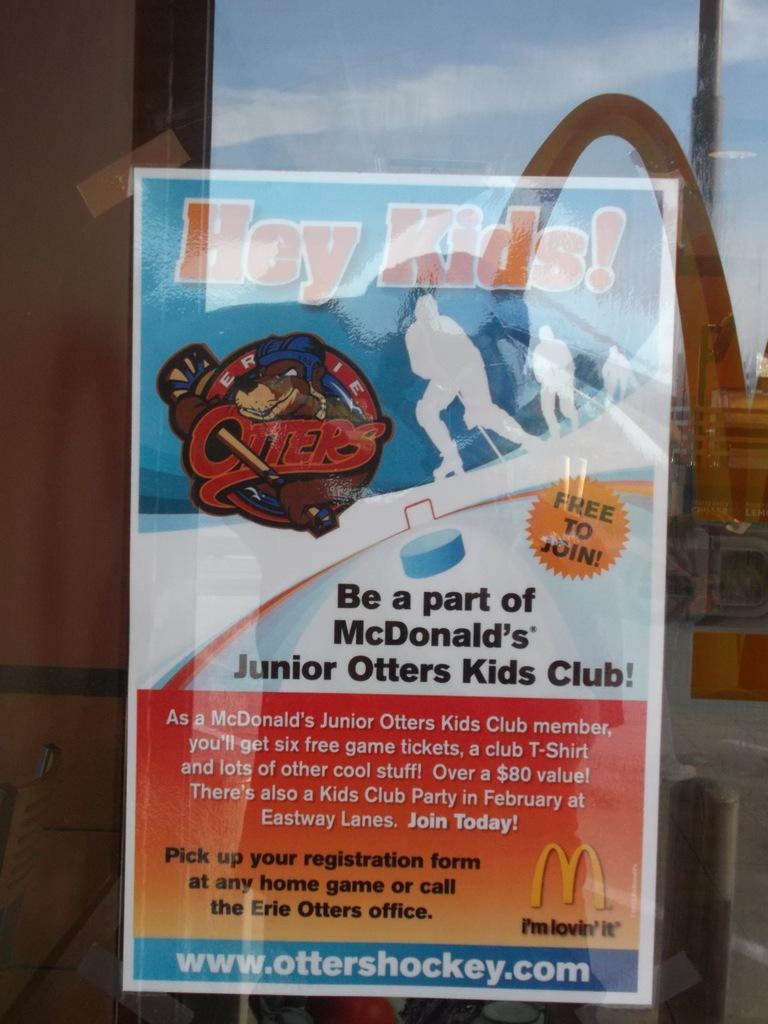<image>
Offer a succinct explanation of the picture presented. A sign inviting kids to join McDonald's Junior Otters  Kids Club is displayed in a window. 